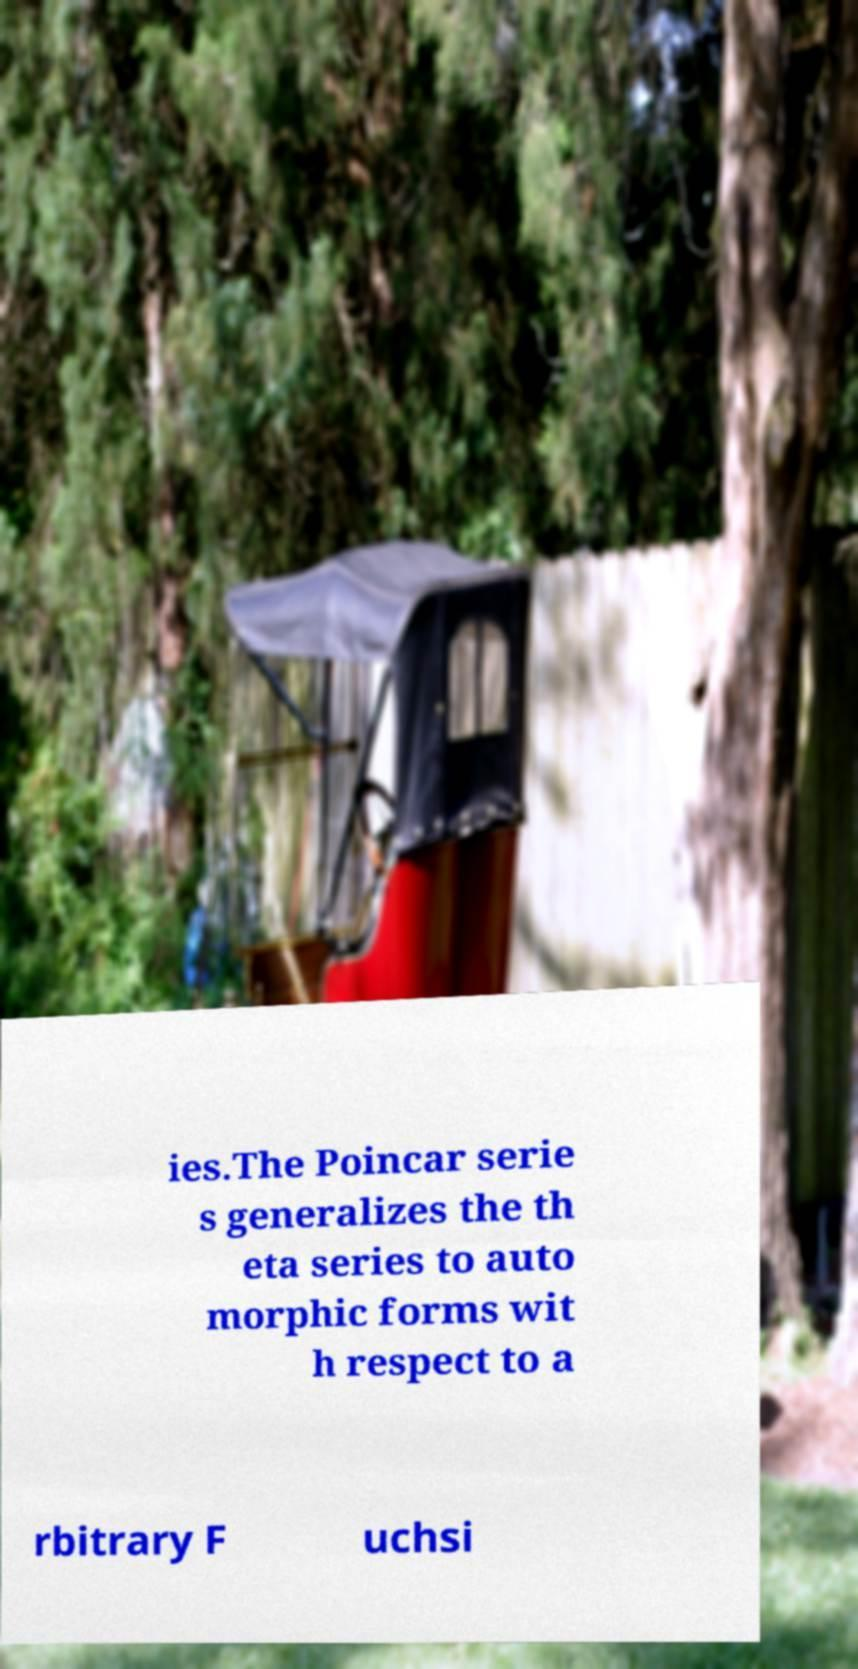There's text embedded in this image that I need extracted. Can you transcribe it verbatim? ies.The Poincar serie s generalizes the th eta series to auto morphic forms wit h respect to a rbitrary F uchsi 